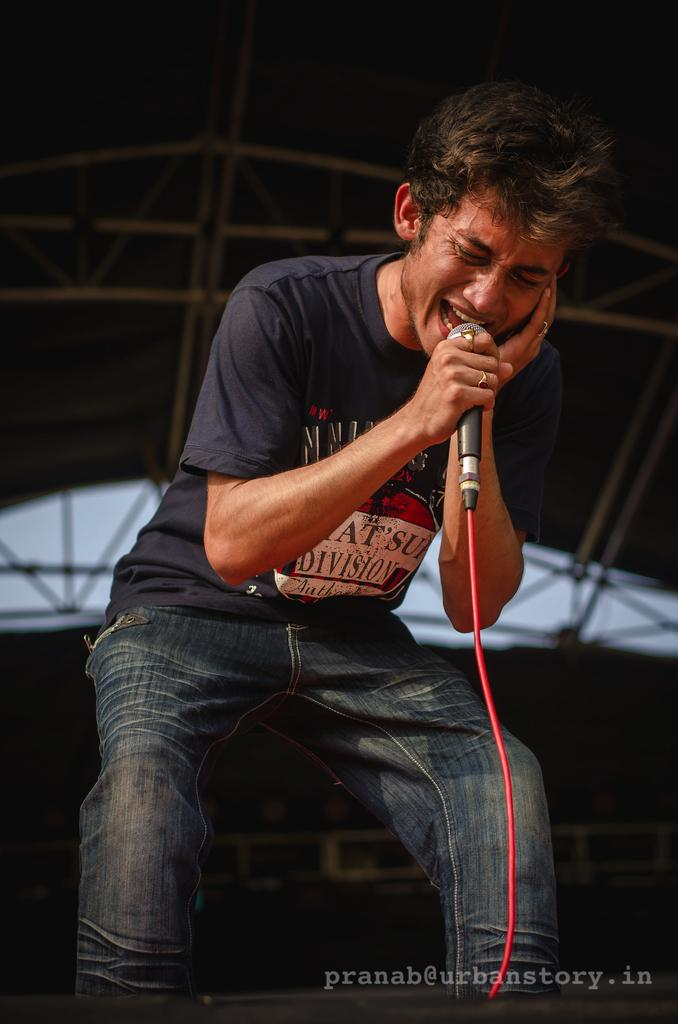What is the man in the image doing? The man is singing in the image. What is the man using to amplify his voice? The man is using a microphone in the image. What can be seen in the background of the image? There are metal rods in the background of the image. How many cherries are on the man's head in the image? There are no cherries present on the man's head in the image. What is the man thinking about while singing in the image? The image does not provide information about the man's thoughts, so we cannot determine what he is thinking about. 